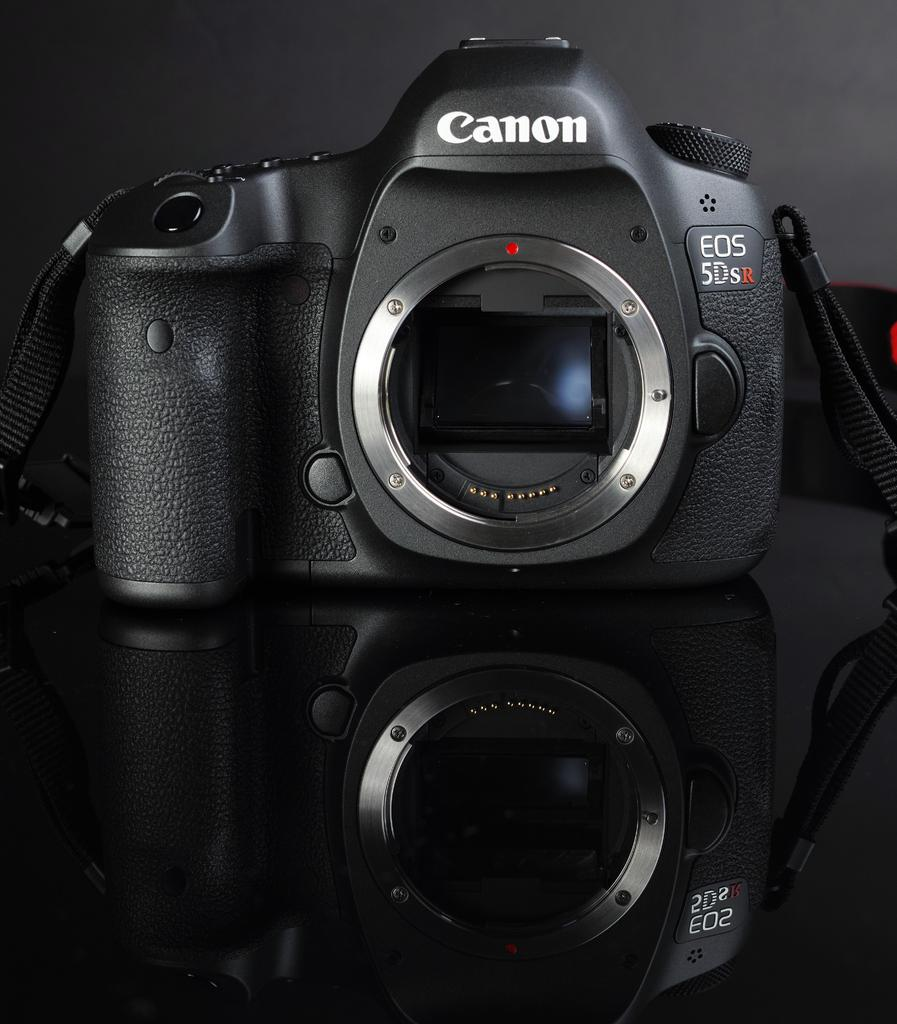<image>
Give a short and clear explanation of the subsequent image. A Canon camera sits on a reflective black surface. 